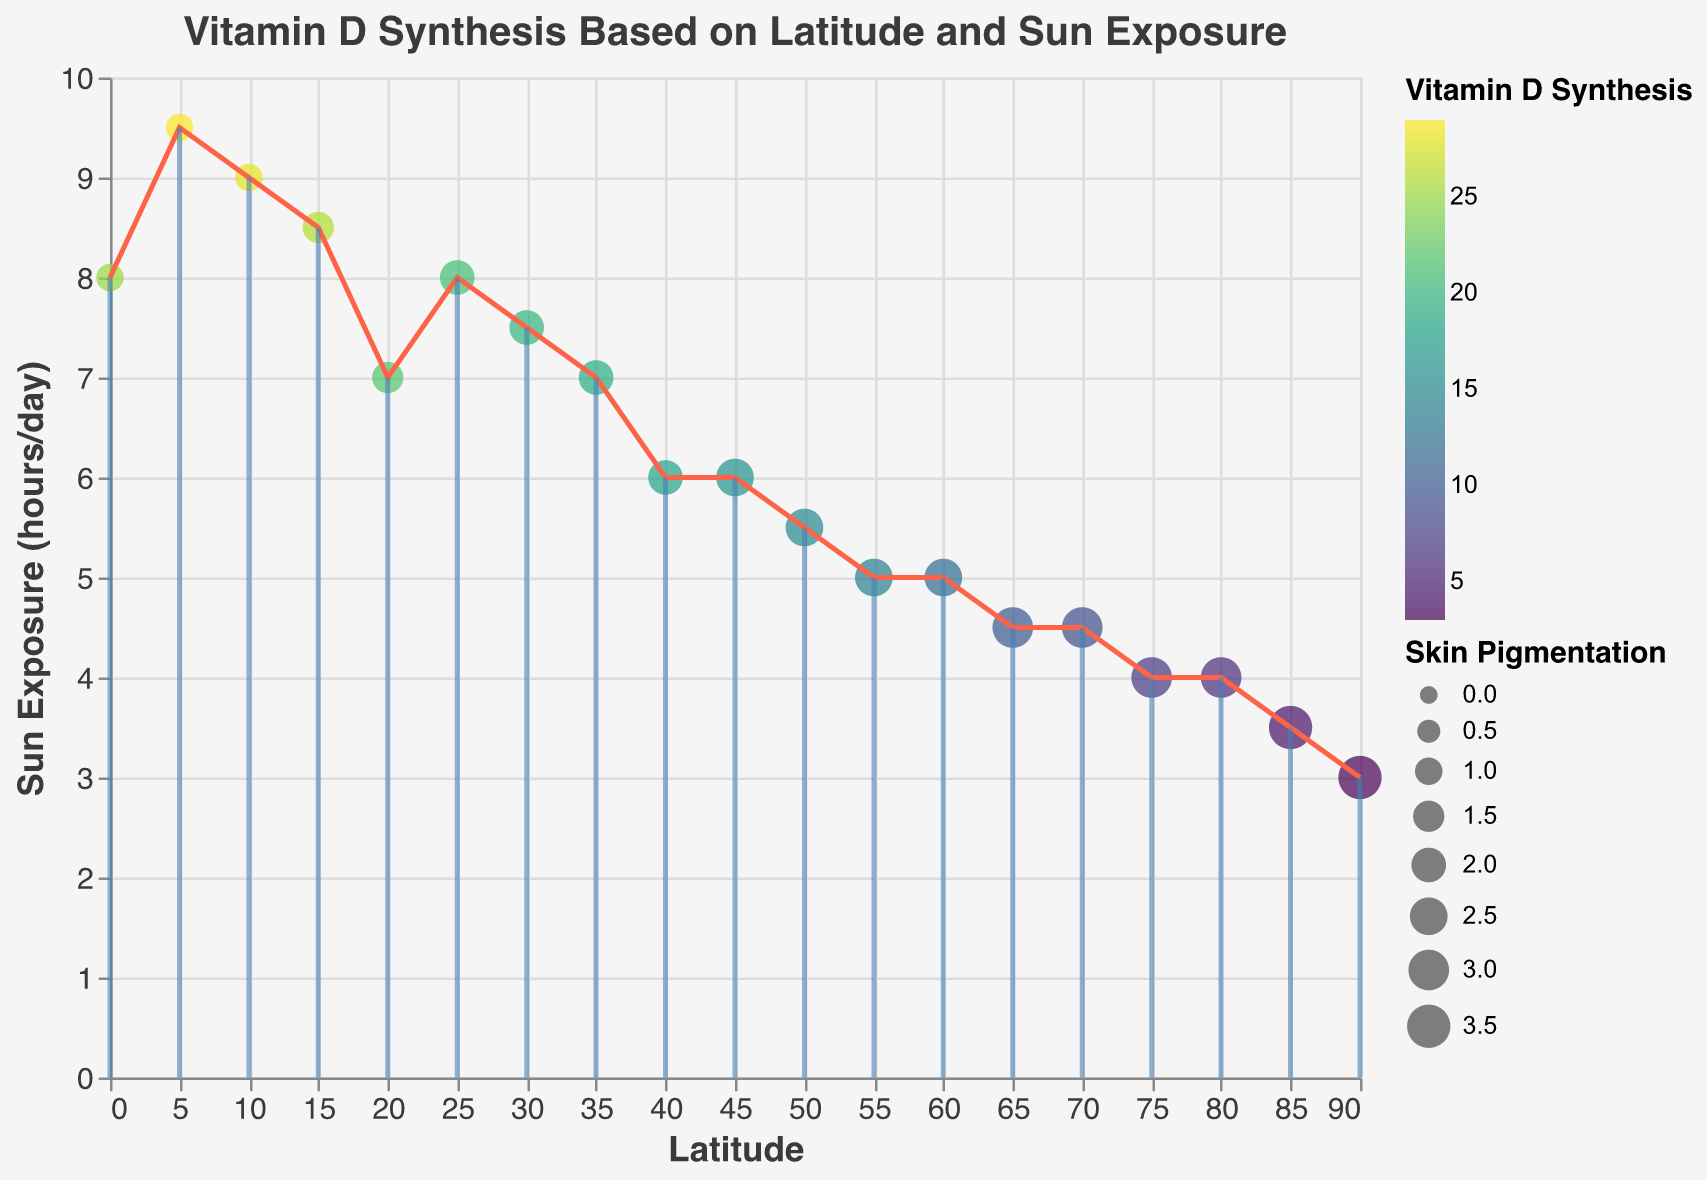What is the title of the plot? The title is displayed at the top of the figure in a larger font size.
Answer: Vitamin D Synthesis Based on Latitude and Sun Exposure How does Vitamin D synthesis vary with latitude? Look at the color gradient of the data points based on the "VitaminDSynthesis" field. Darker colors indicate higher values of Vitamin D synthesis. Points closer to the equator (lower latitudes) generally have darker colors.
Answer: It decreases as latitude increases At which latitude and sun exposure is the highest Vitamin D synthesis observed? Locate the point with the darkest color indicating the highest Vitamin D synthesis. Cross-reference it with the latitude and sun exposure on the axes.
Answer: Latitude: 5, Sun Exposure: 9.5 What is the range of skin pigmentation in the data? Look at the size of the points, which corresponds to skin pigmentation. The legend indicates the smallest and largest values of skin pigmentation.
Answer: From 1 to 3.5 Compare the Vitamin D synthesis at latitude 10 and 80. Locate the points at latitude 10 and 80, and compare their colors. According to the legend, darker colors represent higher Vitamin D synthesis.
Answer: Latitude 10 has 28, Latitude 80 has 6 Which data point has the maximum sun exposure, and what is its Vitamin D synthesis level? Find the point furthest to the right on the Sun Exposure axis. Check the color of this point to determine the Vitamin D synthesis level.
Answer: Latitude: 5, Vitamin D synthesis: 29 How does the sun exposure change with latitude? Look at the plotted points from left to right along the Latitude axis and observe the trend in their vertical position on the Sun Exposure axis.
Answer: It generally decreases as latitude increases What is the average Vitamin D synthesis level for latitudes between 40 and 60? Identify data points between latitude 40 and 60. Sum their Vitamin D synthesis levels and divide by the number of these data points.
Answer: \( (18 + 12 + 20) / 3 = 50 / 3 \approx 16.67 \) How does seasonal variation influence the plot? Seasonal variation is represented by the angle of the rules. Observe the direction and length of the rules at different latitudes to understand the seasonal impact.
Answer: Seasonal variation increases as latitude increases, indicated by more tilted rules 